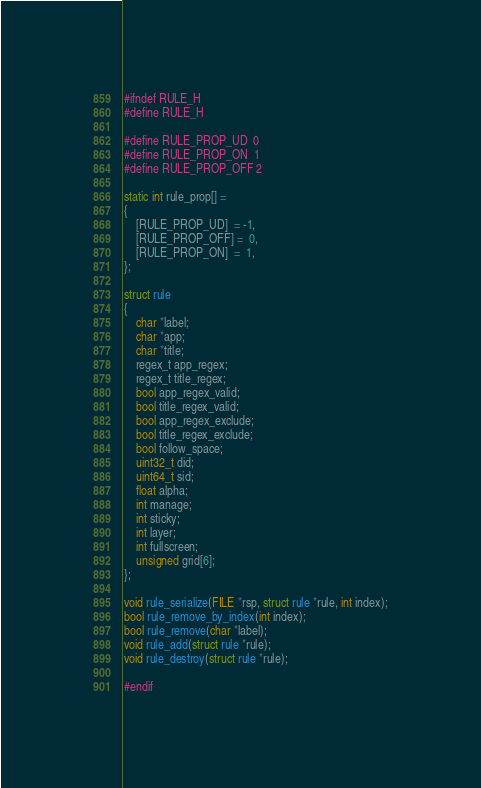Convert code to text. <code><loc_0><loc_0><loc_500><loc_500><_C_>#ifndef RULE_H
#define RULE_H

#define RULE_PROP_UD  0
#define RULE_PROP_ON  1
#define RULE_PROP_OFF 2

static int rule_prop[] =
{
    [RULE_PROP_UD]  = -1,
    [RULE_PROP_OFF] =  0,
    [RULE_PROP_ON]  =  1,
};

struct rule
{
    char *label;
    char *app;
    char *title;
    regex_t app_regex;
    regex_t title_regex;
    bool app_regex_valid;
    bool title_regex_valid;
    bool app_regex_exclude;
    bool title_regex_exclude;
    bool follow_space;
    uint32_t did;
    uint64_t sid;
    float alpha;
    int manage;
    int sticky;
    int layer;
    int fullscreen;
    unsigned grid[6];
};

void rule_serialize(FILE *rsp, struct rule *rule, int index);
bool rule_remove_by_index(int index);
bool rule_remove(char *label);
void rule_add(struct rule *rule);
void rule_destroy(struct rule *rule);

#endif
</code> 